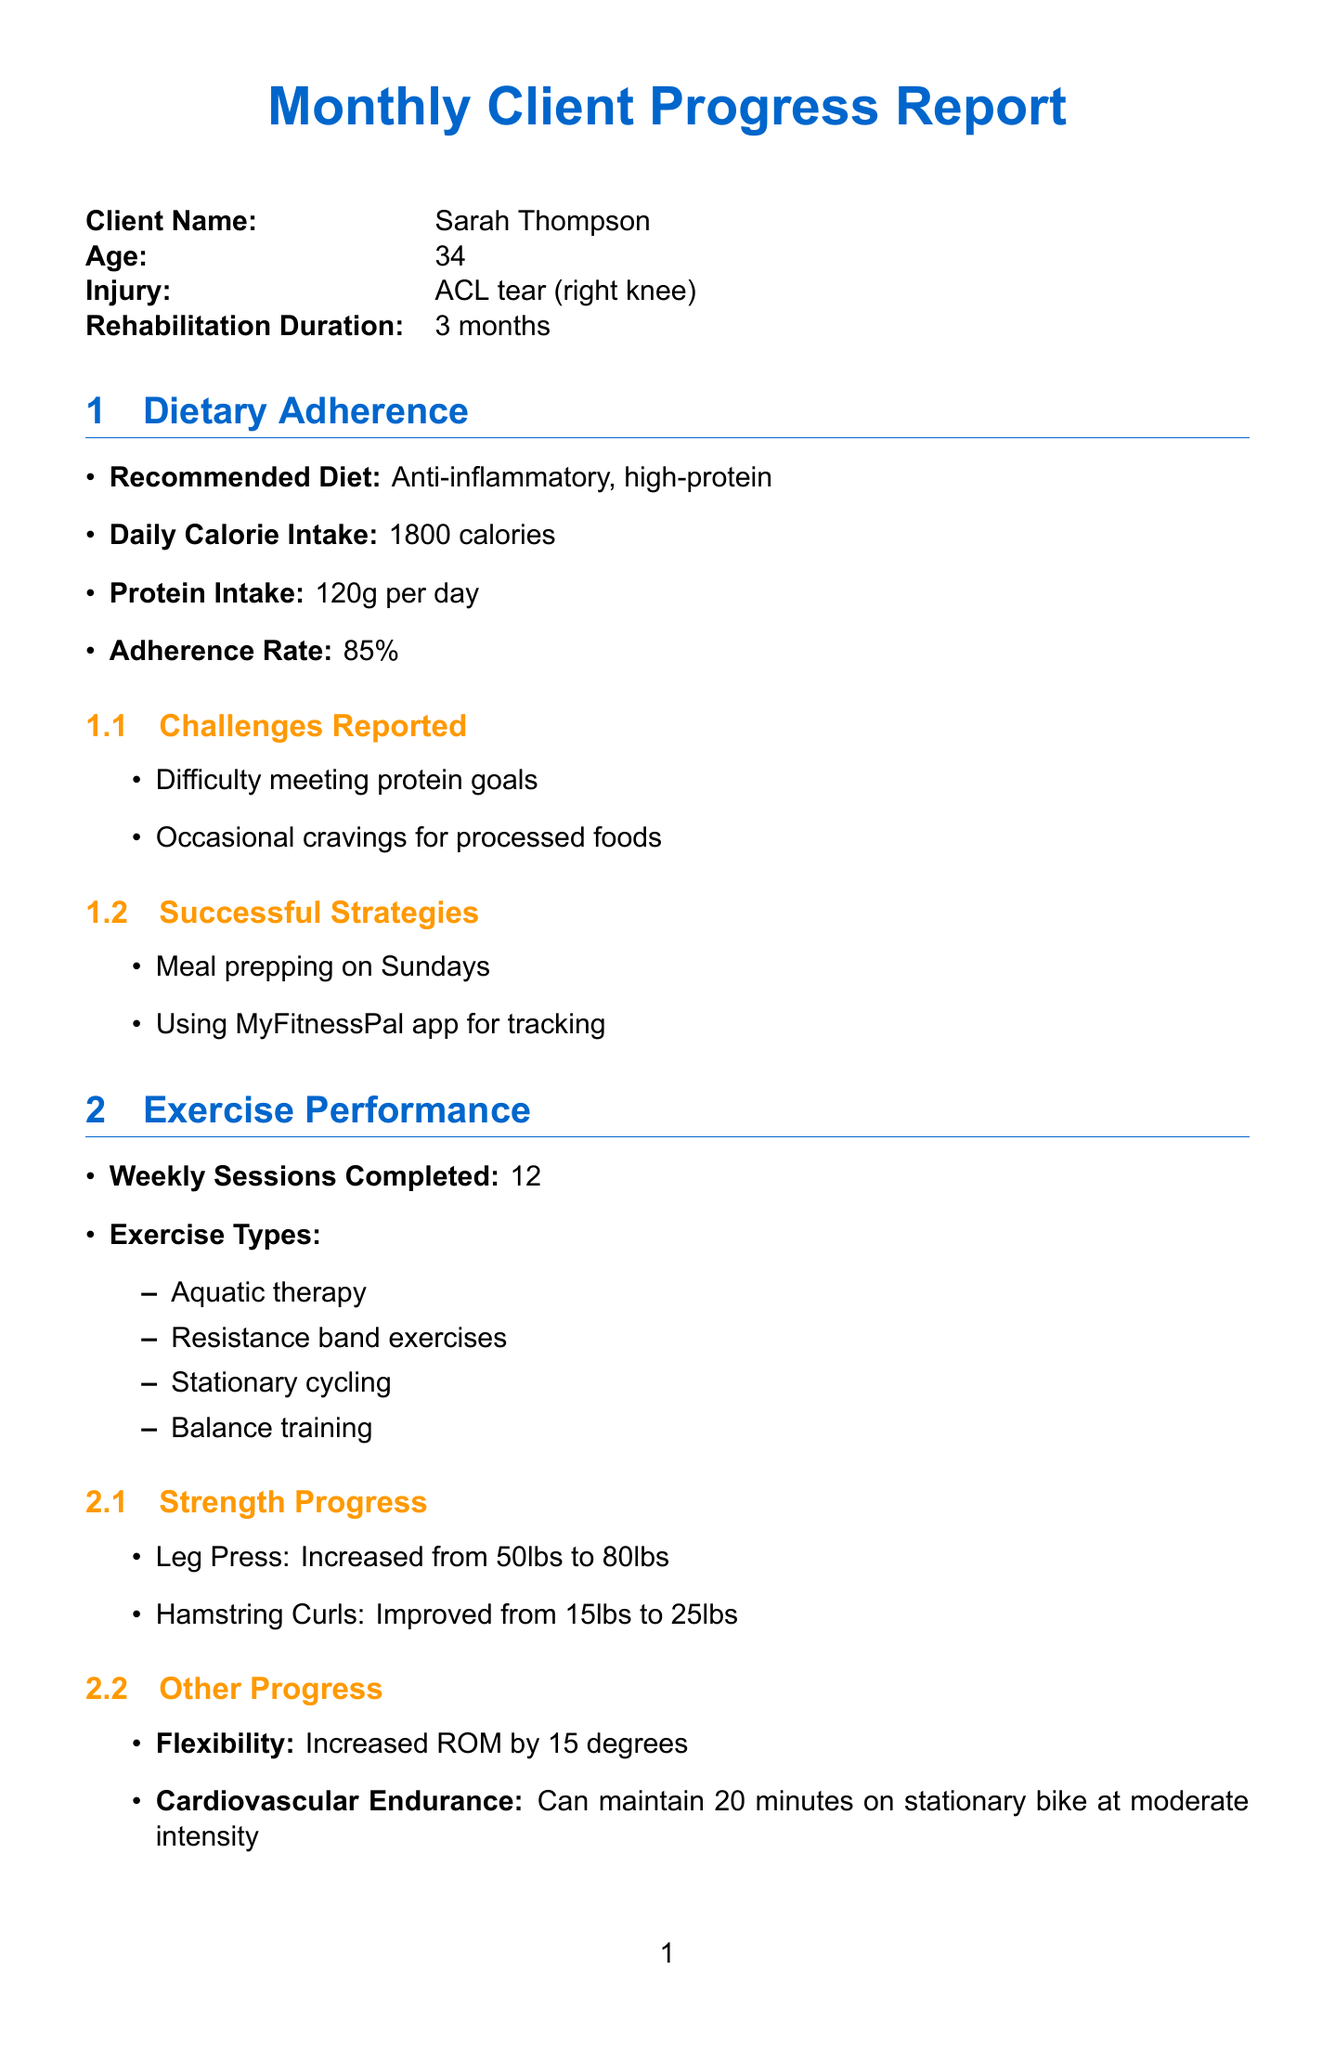what is the name of the client? The name of the client is mentioned in the client details section of the document.
Answer: Sarah Thompson what is the injury sustained by the client? The injury information is provided under client details.
Answer: ACL tear (right knee) what is the protein intake recommendation? The recommended protein intake is listed in the dietary adherence section.
Answer: 120g per day how many weekly exercise sessions did the client complete? The number of completed exercise sessions is mentioned in the exercise performance section.
Answer: 12 what was the achievement date for full weight-bearing without crutches? The achievement date is detailed in the recovery milestones section of the document.
Answer: 2023-05-15 what is the current pain level reported by the client? The current pain level can be found in the pain management section.
Answer: 2/10 what dietary change is suggested in the program adjustments? The specific dietary change is specified in the program adjustments section.
Answer: Increase daily protein intake to 130g what types of exercises are included in the client's routine? The types of exercises are listed in the exercise performance section.
Answer: Aquatic therapy, Resistance band exercises, Stationary cycling, Balance training what is the overall satisfaction rating from the client? The overall satisfaction is provided in the client feedback section.
Answer: 8/10 